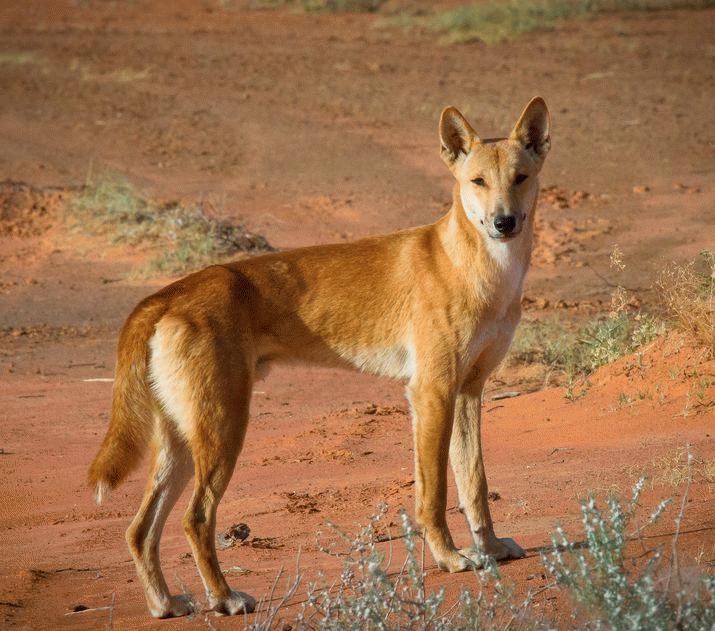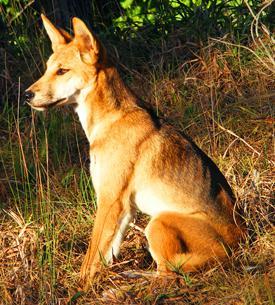The first image is the image on the left, the second image is the image on the right. Evaluate the accuracy of this statement regarding the images: "The dog in the right image is on a grassy surface.". Is it true? Answer yes or no. Yes. 